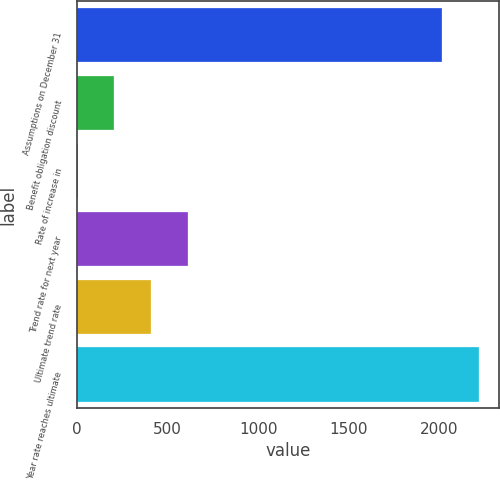<chart> <loc_0><loc_0><loc_500><loc_500><bar_chart><fcel>Assumptions on December 31<fcel>Benefit obligation discount<fcel>Rate of increase in<fcel>Trend rate for next year<fcel>Ultimate trend rate<fcel>Year rate reaches ultimate<nl><fcel>2017<fcel>204.94<fcel>2.82<fcel>609.18<fcel>407.06<fcel>2219.12<nl></chart> 